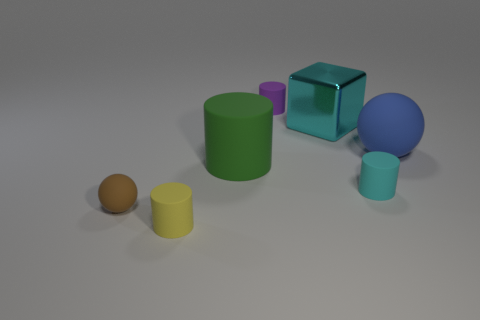Is the cyan metallic object the same shape as the big green rubber thing?
Your answer should be very brief. No. What number of rubber things are either green cylinders or big cyan balls?
Provide a succinct answer. 1. How many brown metallic spheres are there?
Offer a terse response. 0. The rubber ball that is the same size as the shiny cube is what color?
Your answer should be very brief. Blue. Does the cyan rubber cylinder have the same size as the green object?
Your answer should be very brief. No. What shape is the rubber object that is the same color as the big metal cube?
Ensure brevity in your answer.  Cylinder. There is a cube; does it have the same size as the purple matte cylinder that is behind the large cyan block?
Provide a short and direct response. No. What is the color of the cylinder that is to the right of the green rubber thing and behind the tiny cyan thing?
Your answer should be compact. Purple. Are there more small brown rubber objects on the right side of the purple cylinder than tiny purple matte things left of the green cylinder?
Make the answer very short. No. What is the size of the yellow cylinder that is made of the same material as the big green object?
Provide a short and direct response. Small. 